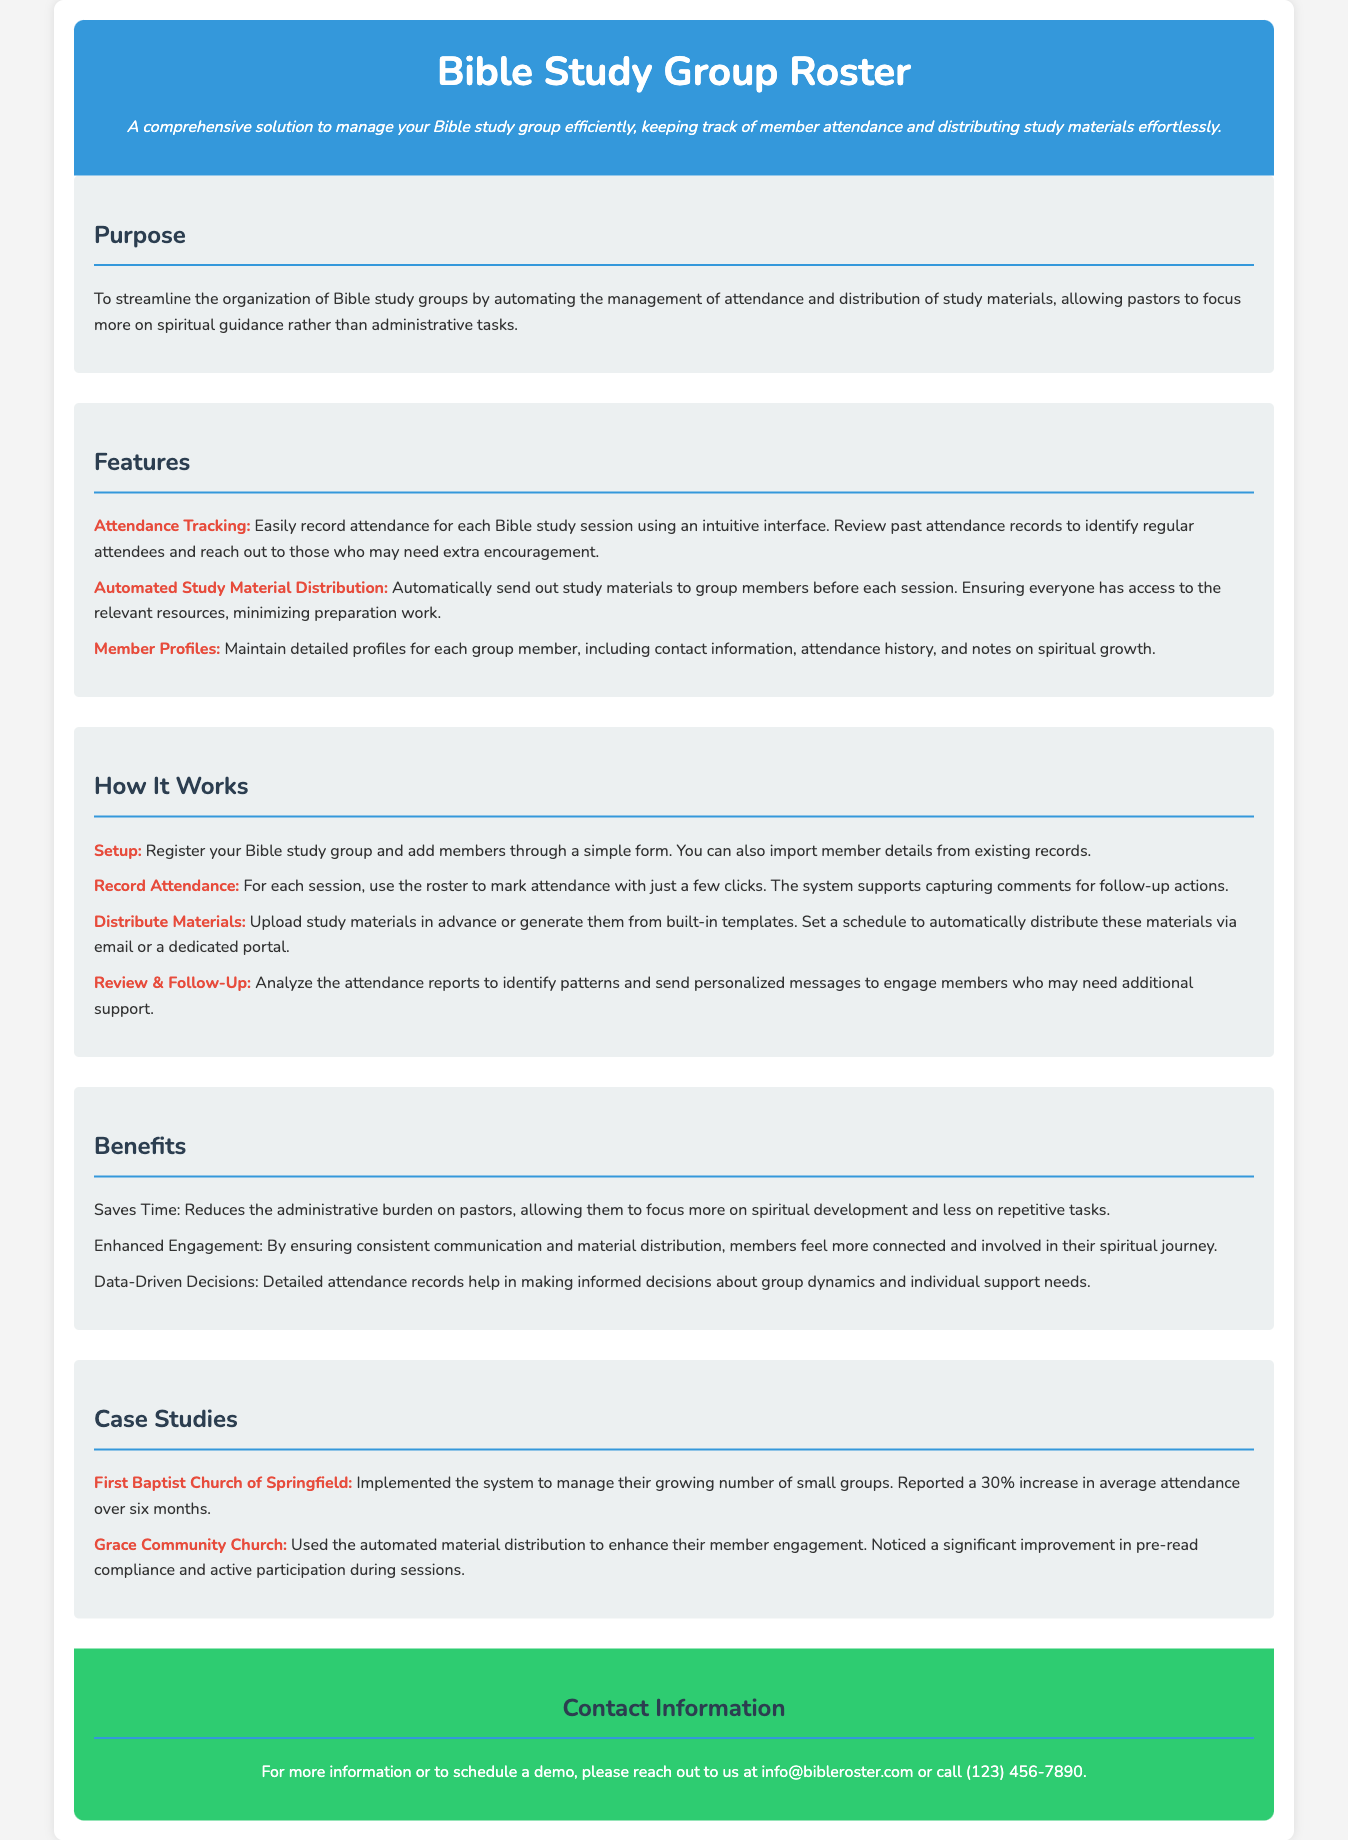What is the title of the document? The title appears in the header section of the document.
Answer: Bible Study Group Roster What is the main purpose of the document? The purpose is clearly outlined under its specific section, explaining what the document aims to achieve.
Answer: To streamline the organization of Bible study groups How many case studies are mentioned? The total number of case studies can be counted from the list provided in the respective section.
Answer: Two What color is used for the header background? The background color of the header is described in the style section.
Answer: #3498db What contact information is provided? The contact information is detailed in the contact section, including email and phone number.
Answer: info@bibleroster.com or call (123) 456-7890 What feature allows tracking of member engagement? A specific feature is designated for engagement tracking in the features list.
Answer: Attendance Tracking Which church reported a 30% increase in attendance? The church name is stated in the case studies section, indicating their success.
Answer: First Baptist Church of Springfield How are study materials distributed? The method of distribution is specified within a step of the "How It Works" section.
Answer: Automatically send out study materials What is one benefit of using the system? The benefits are listed, highlighting advantages gained from the system implementation.
Answer: Saves Time 